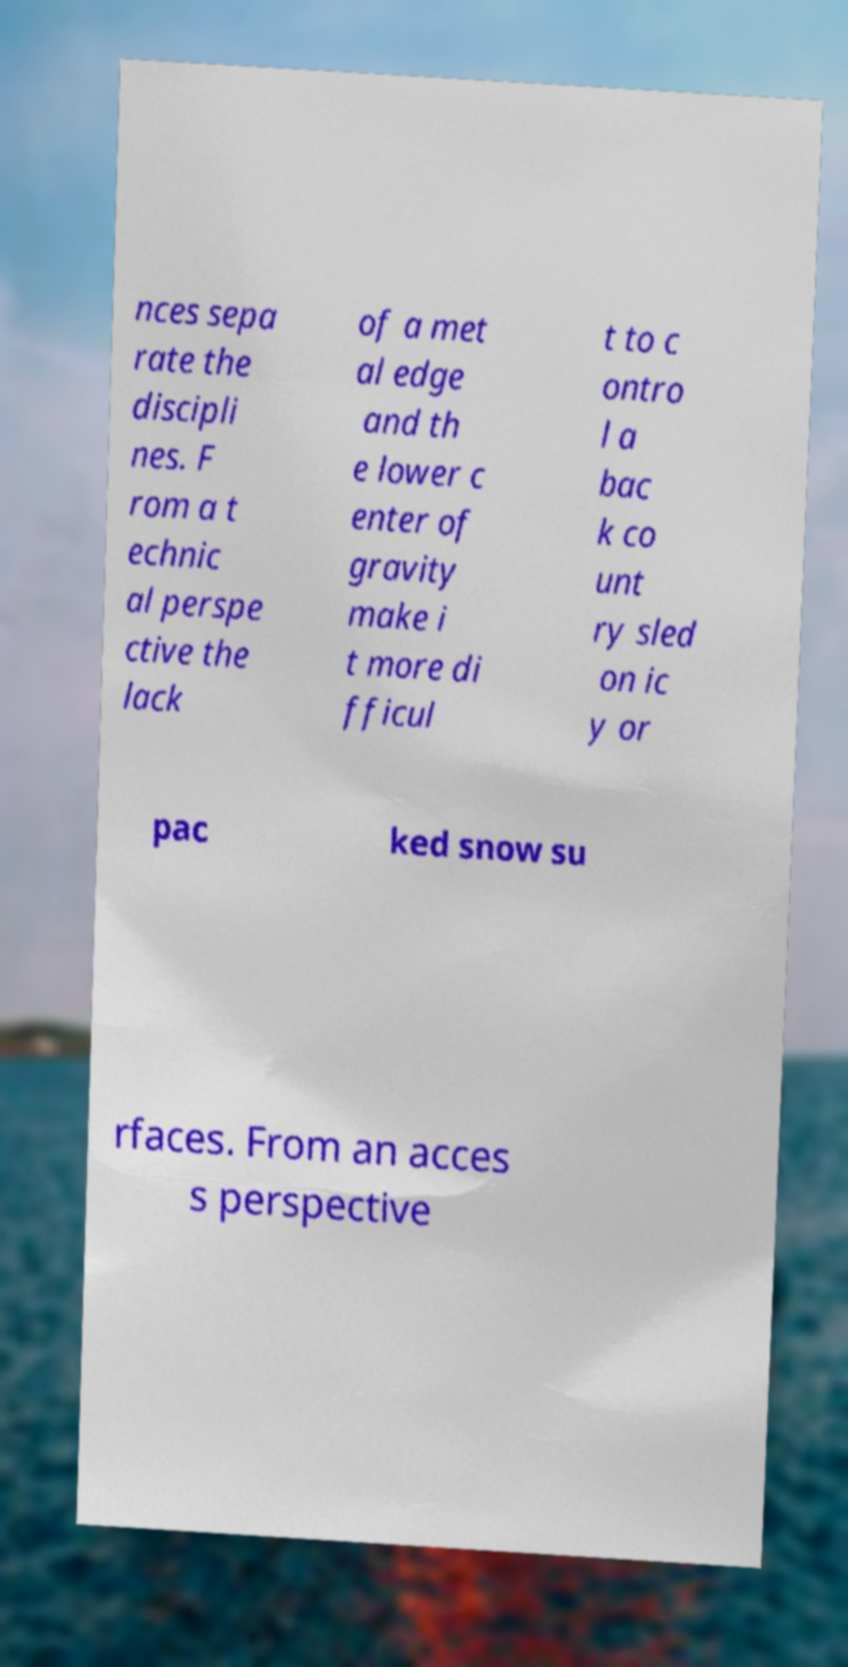Could you extract and type out the text from this image? nces sepa rate the discipli nes. F rom a t echnic al perspe ctive the lack of a met al edge and th e lower c enter of gravity make i t more di fficul t to c ontro l a bac k co unt ry sled on ic y or pac ked snow su rfaces. From an acces s perspective 